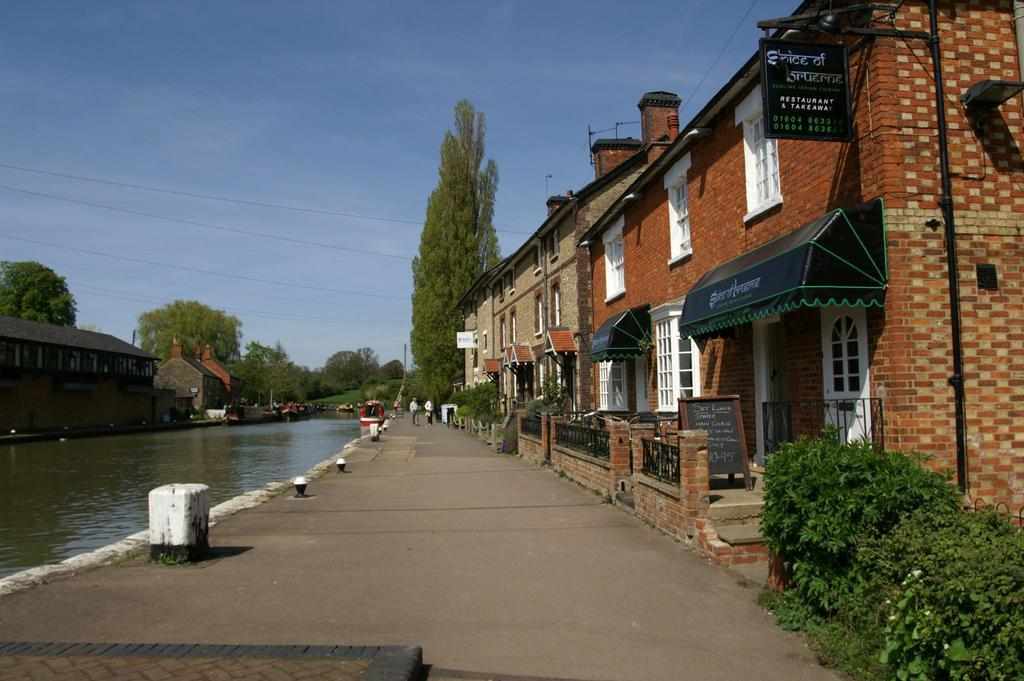How many persons are walking in the image? There are two persons walking in the image. What surface are the persons walking on? The persons are walking on a path. What natural element can be seen in the image? Water is visible in the image. What type of structures are present in the image? There are buildings with windows in the image. What type of vegetation is present in the image? Trees are present in the image. What type of shade is visible in the image? Sun shades are visible in the image. What type of sign is present in the image? There is a name board in the image. What is visible in the background of the image? The sky with clouds is visible in the background of the image. How many nerves are visible in the image? There are no nerves visible in the image, as it is a scene of two persons walking and does not involve any biological structures. 